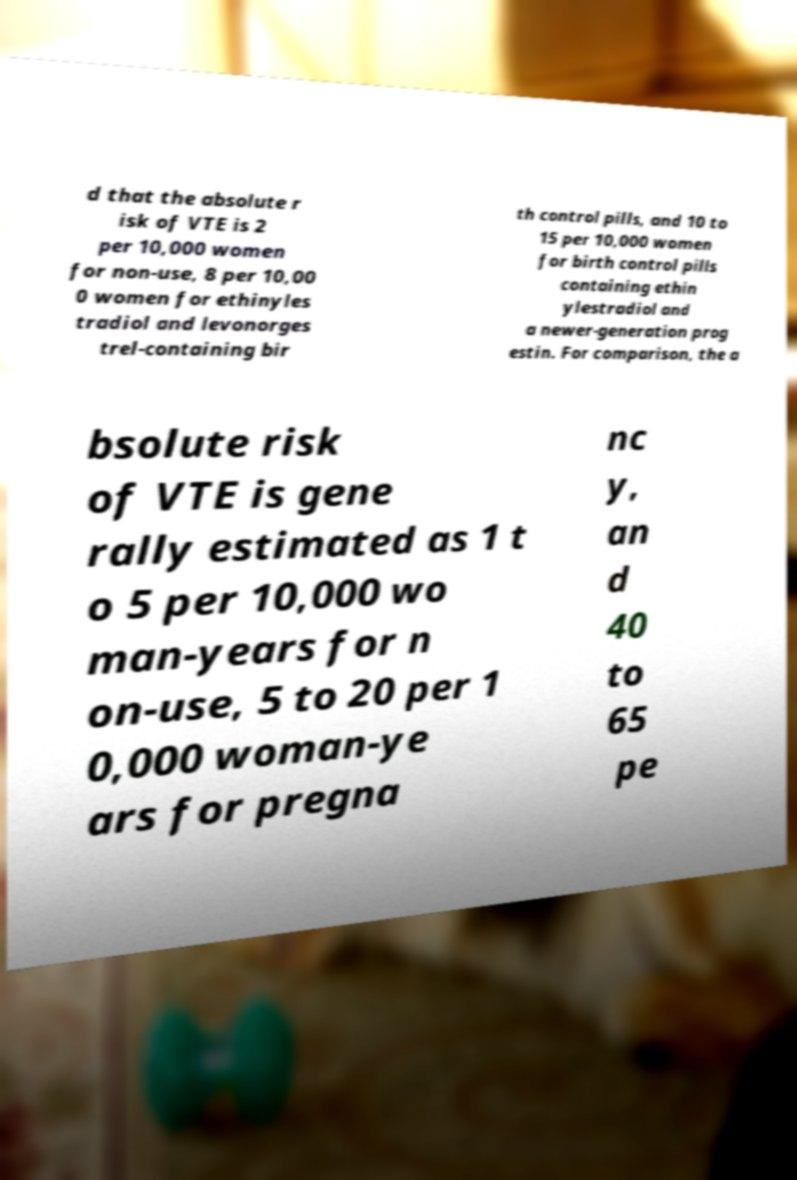Could you extract and type out the text from this image? d that the absolute r isk of VTE is 2 per 10,000 women for non-use, 8 per 10,00 0 women for ethinyles tradiol and levonorges trel-containing bir th control pills, and 10 to 15 per 10,000 women for birth control pills containing ethin ylestradiol and a newer-generation prog estin. For comparison, the a bsolute risk of VTE is gene rally estimated as 1 t o 5 per 10,000 wo man-years for n on-use, 5 to 20 per 1 0,000 woman-ye ars for pregna nc y, an d 40 to 65 pe 